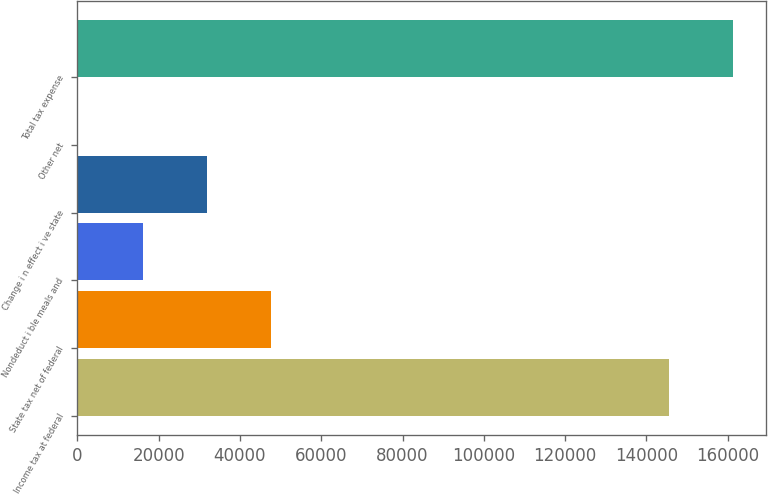Convert chart. <chart><loc_0><loc_0><loc_500><loc_500><bar_chart><fcel>Income tax at federal<fcel>State tax net of federal<fcel>Nondeduct i ble meals and<fcel>Change i n effect i ve state<fcel>Other net<fcel>Total tax expense<nl><fcel>145506<fcel>47744.1<fcel>16034.7<fcel>31889.4<fcel>180<fcel>161361<nl></chart> 